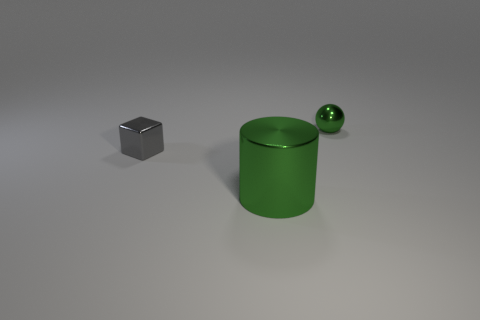Are there fewer green metallic objects in front of the gray metal block than things to the left of the green ball?
Your answer should be compact. Yes. Is there anything else that is the same size as the cylinder?
Keep it short and to the point. No. What is the shape of the tiny green metal thing?
Keep it short and to the point. Sphere. There is a tiny thing that is behind the gray metallic block; what is it made of?
Your answer should be compact. Metal. What is the size of the green thing that is behind the tiny shiny object to the left of the green object that is in front of the gray metallic block?
Offer a terse response. Small. Does the small thing that is in front of the tiny green shiny sphere have the same material as the green thing in front of the green metal ball?
Ensure brevity in your answer.  Yes. What number of other objects are the same color as the block?
Your answer should be very brief. 0. What number of objects are green objects that are in front of the small green shiny object or metallic things that are in front of the gray cube?
Give a very brief answer. 1. How big is the green metal object behind the tiny object on the left side of the big metal thing?
Provide a short and direct response. Small. The gray thing has what size?
Offer a very short reply. Small. 